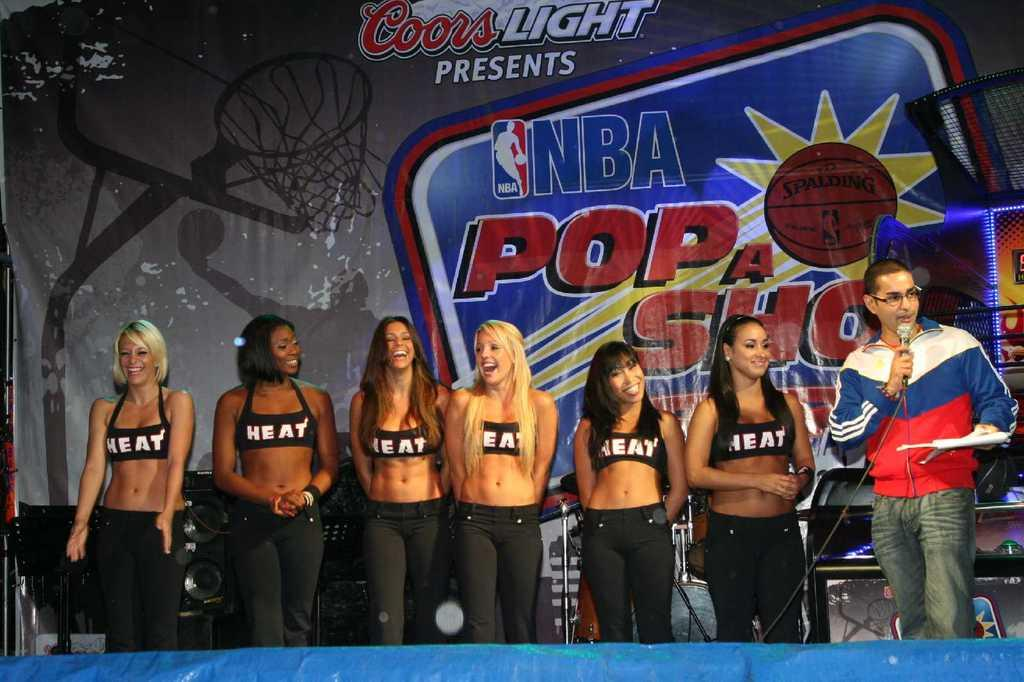Provide a one-sentence caption for the provided image. A lineup of women with tops that say HEAt stand with a man in front of an NBA backdrop. 